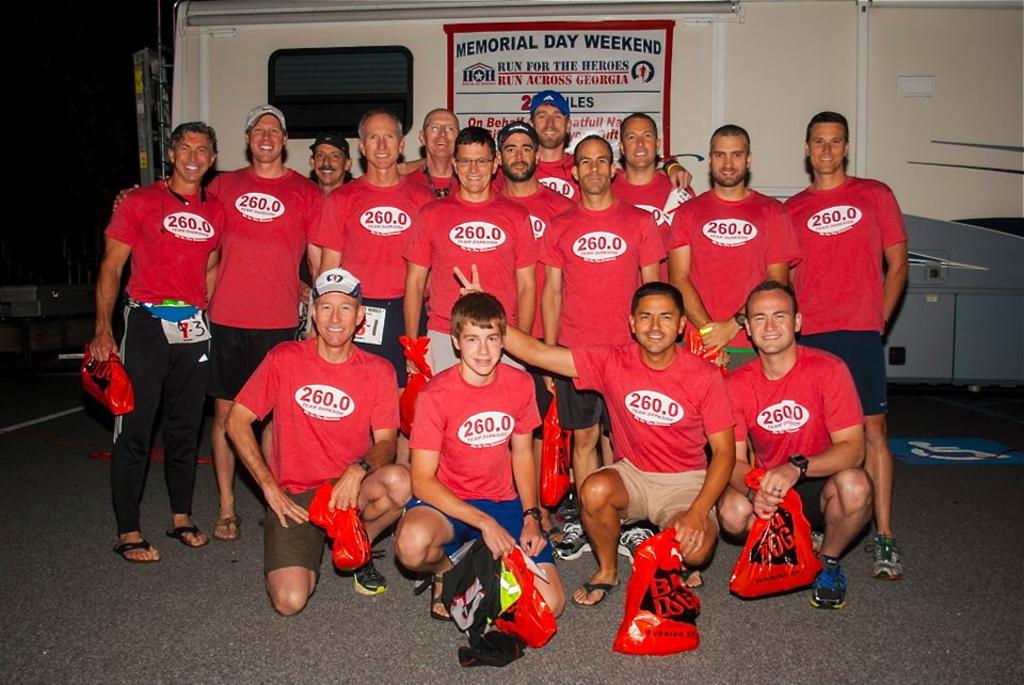What is the number on their shirts?
Your answer should be very brief. 260.0. What holiday is on the banner?
Ensure brevity in your answer.  Memorial day. 